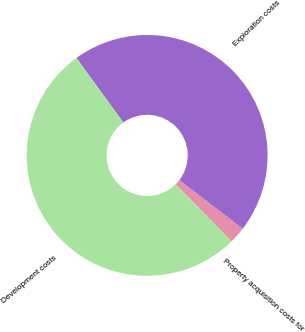Convert chart to OTSL. <chart><loc_0><loc_0><loc_500><loc_500><pie_chart><fcel>Property acquisition costs for<fcel>Exploration costs<fcel>Development costs<nl><fcel>2.22%<fcel>45.41%<fcel>52.38%<nl></chart> 